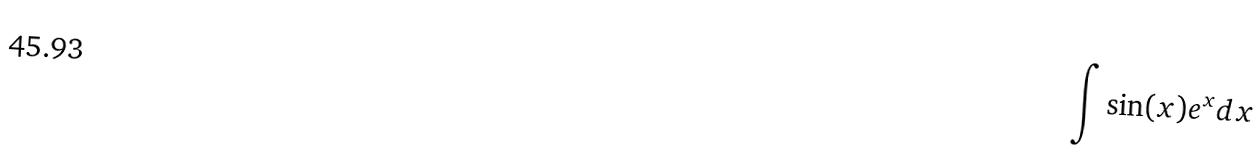Convert formula to latex. <formula><loc_0><loc_0><loc_500><loc_500>\int \sin ( x ) e ^ { x } d x</formula> 